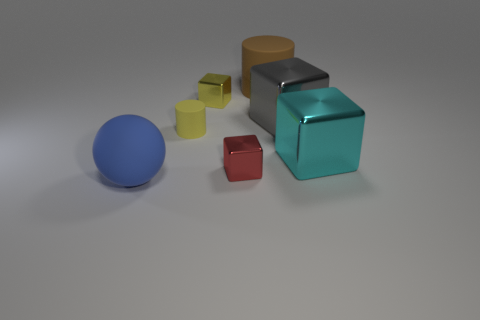There is a large object that is the same shape as the small matte thing; what is it made of?
Give a very brief answer. Rubber. There is a rubber cylinder right of the red metallic object; what is its color?
Make the answer very short. Brown. How big is the gray thing?
Your response must be concise. Large. There is a yellow metallic cube; is its size the same as the rubber cylinder left of the red shiny thing?
Provide a short and direct response. Yes. There is a cylinder that is left of the big brown thing behind the tiny cylinder that is on the left side of the large cyan object; what is its color?
Ensure brevity in your answer.  Yellow. Are the tiny yellow thing right of the small matte thing and the red cube made of the same material?
Your response must be concise. Yes. How many other objects are there of the same material as the gray thing?
Offer a terse response. 3. What is the material of the cyan thing that is the same size as the brown rubber cylinder?
Your answer should be compact. Metal. Does the matte thing right of the tiny red block have the same shape as the cyan object that is in front of the tiny rubber thing?
Give a very brief answer. No. What is the shape of the brown matte object that is the same size as the blue matte thing?
Offer a terse response. Cylinder. 